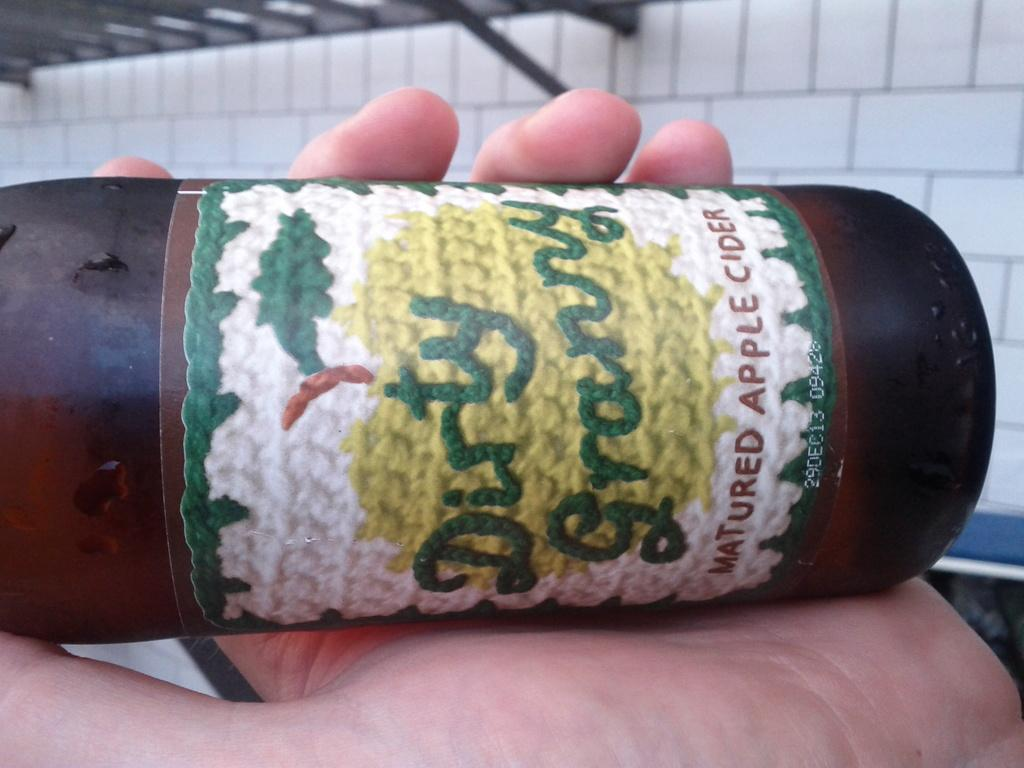<image>
Describe the image concisely. A bottle of Dirty Granny Apple cider in a persons hand. 